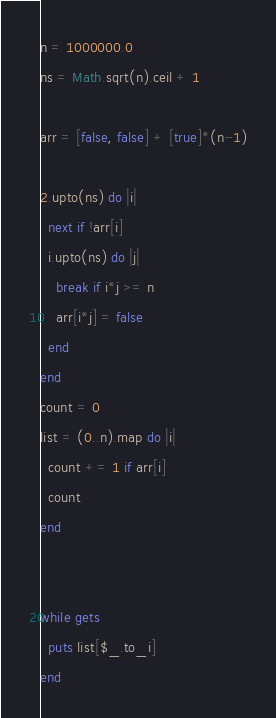<code> <loc_0><loc_0><loc_500><loc_500><_Ruby_>n = 1000000.0
ns = Math.sqrt(n).ceil + 1

arr = [false, false] + [true]*(n-1)

2.upto(ns) do |i|
  next if !arr[i]
  i.upto(ns) do |j|
    break if i*j >= n
    arr[i*j] = false
  end
end
count = 0
list = (0..n).map do |i|
  count += 1 if arr[i]
  count
end


while gets
  puts list[$_.to_i]
end</code> 